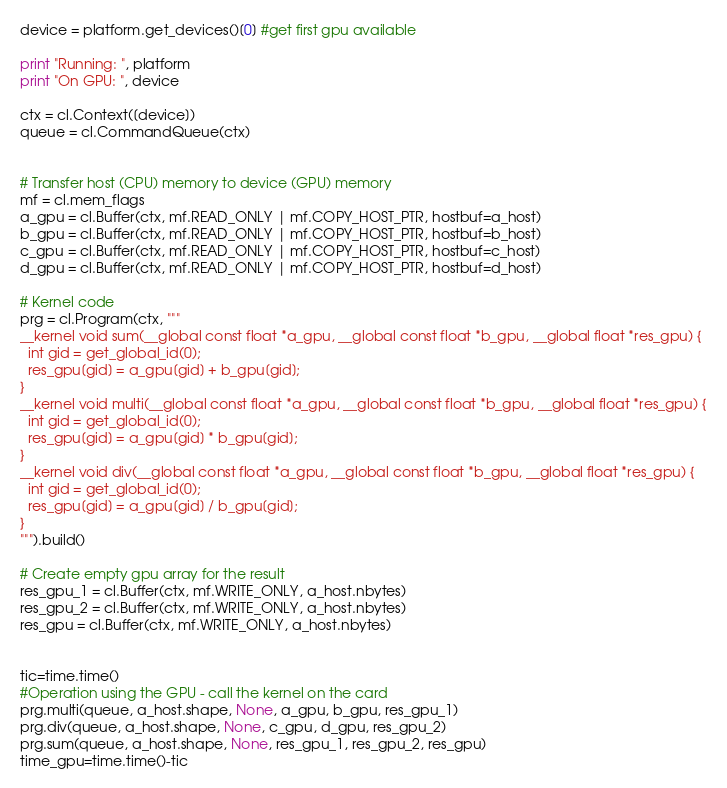Convert code to text. <code><loc_0><loc_0><loc_500><loc_500><_Python_>device = platform.get_devices()[0] #get first gpu available

print "Running: ", platform
print "On GPU: ", device

ctx = cl.Context([device])
queue = cl.CommandQueue(ctx)


# Transfer host (CPU) memory to device (GPU) memory 
mf = cl.mem_flags
a_gpu = cl.Buffer(ctx, mf.READ_ONLY | mf.COPY_HOST_PTR, hostbuf=a_host)
b_gpu = cl.Buffer(ctx, mf.READ_ONLY | mf.COPY_HOST_PTR, hostbuf=b_host)
c_gpu = cl.Buffer(ctx, mf.READ_ONLY | mf.COPY_HOST_PTR, hostbuf=c_host)
d_gpu = cl.Buffer(ctx, mf.READ_ONLY | mf.COPY_HOST_PTR, hostbuf=d_host)

# Kernel code
prg = cl.Program(ctx, """
__kernel void sum(__global const float *a_gpu, __global const float *b_gpu, __global float *res_gpu) {
  int gid = get_global_id(0);
  res_gpu[gid] = a_gpu[gid] + b_gpu[gid];
}
__kernel void multi(__global const float *a_gpu, __global const float *b_gpu, __global float *res_gpu) {
  int gid = get_global_id(0);
  res_gpu[gid] = a_gpu[gid] * b_gpu[gid];
}
__kernel void div(__global const float *a_gpu, __global const float *b_gpu, __global float *res_gpu) {
  int gid = get_global_id(0);
  res_gpu[gid] = a_gpu[gid] / b_gpu[gid];
}
""").build()

# Create empty gpu array for the result 
res_gpu_1 = cl.Buffer(ctx, mf.WRITE_ONLY, a_host.nbytes)
res_gpu_2 = cl.Buffer(ctx, mf.WRITE_ONLY, a_host.nbytes)
res_gpu = cl.Buffer(ctx, mf.WRITE_ONLY, a_host.nbytes)


tic=time.time()
#Operation using the GPU - call the kernel on the card
prg.multi(queue, a_host.shape, None, a_gpu, b_gpu, res_gpu_1)
prg.div(queue, a_host.shape, None, c_gpu, d_gpu, res_gpu_2)
prg.sum(queue, a_host.shape, None, res_gpu_1, res_gpu_2, res_gpu)
time_gpu=time.time()-tic
</code> 